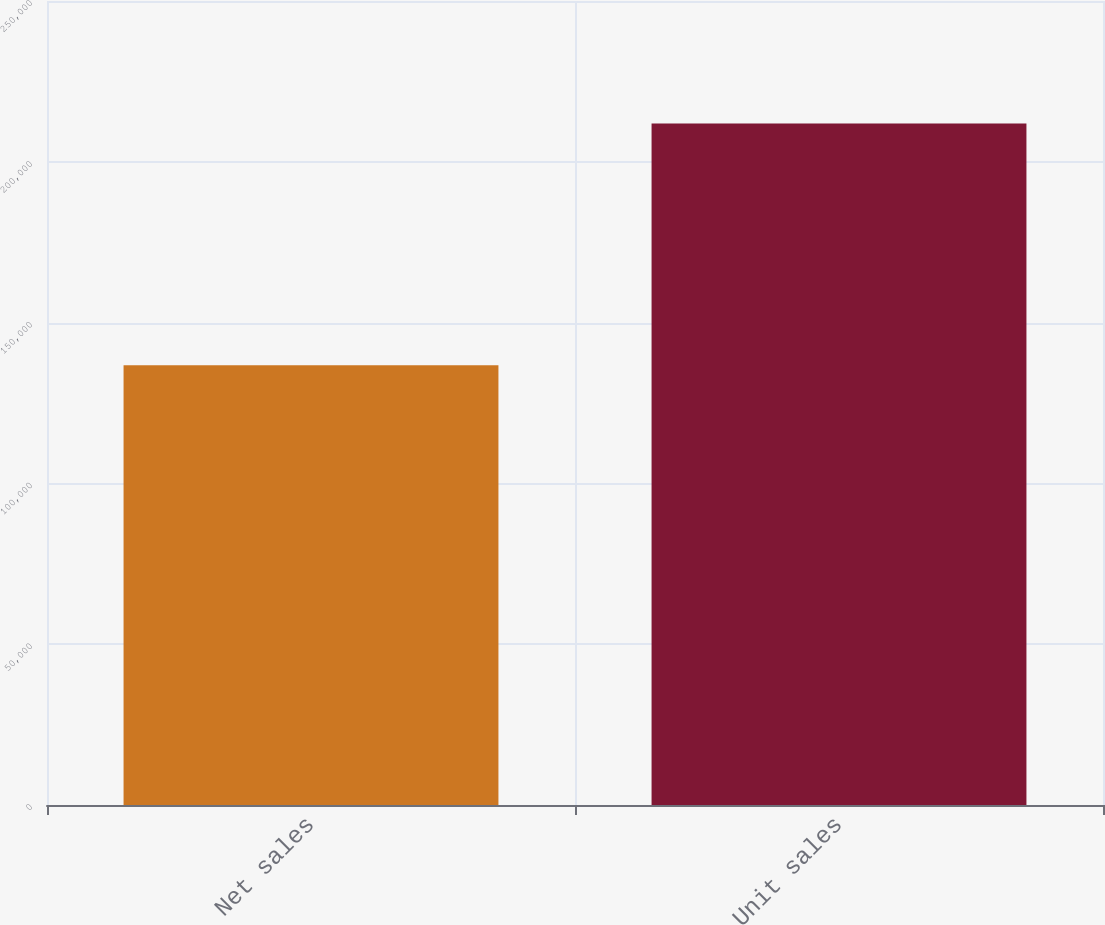Convert chart to OTSL. <chart><loc_0><loc_0><loc_500><loc_500><bar_chart><fcel>Net sales<fcel>Unit sales<nl><fcel>136700<fcel>211884<nl></chart> 